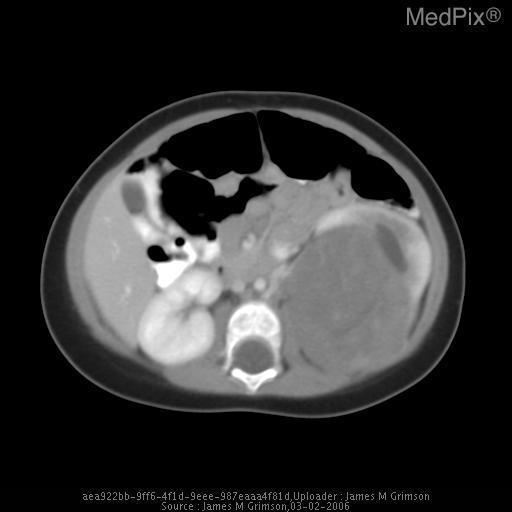How many kidneys are in this image?
Quick response, please. 2. Where is the abnormality in this image?
Short answer required. Left kidney. Where is the lesion located?
Concise answer only. Left kidney. Does the right kidney show signs of hydronephrosis?
Quick response, please. No. Is the right kidney abnormal here?
Be succinct. No. Is the liver lacerated?
Give a very brief answer. No. Is there damage to the liver?
Write a very short answer. No. 